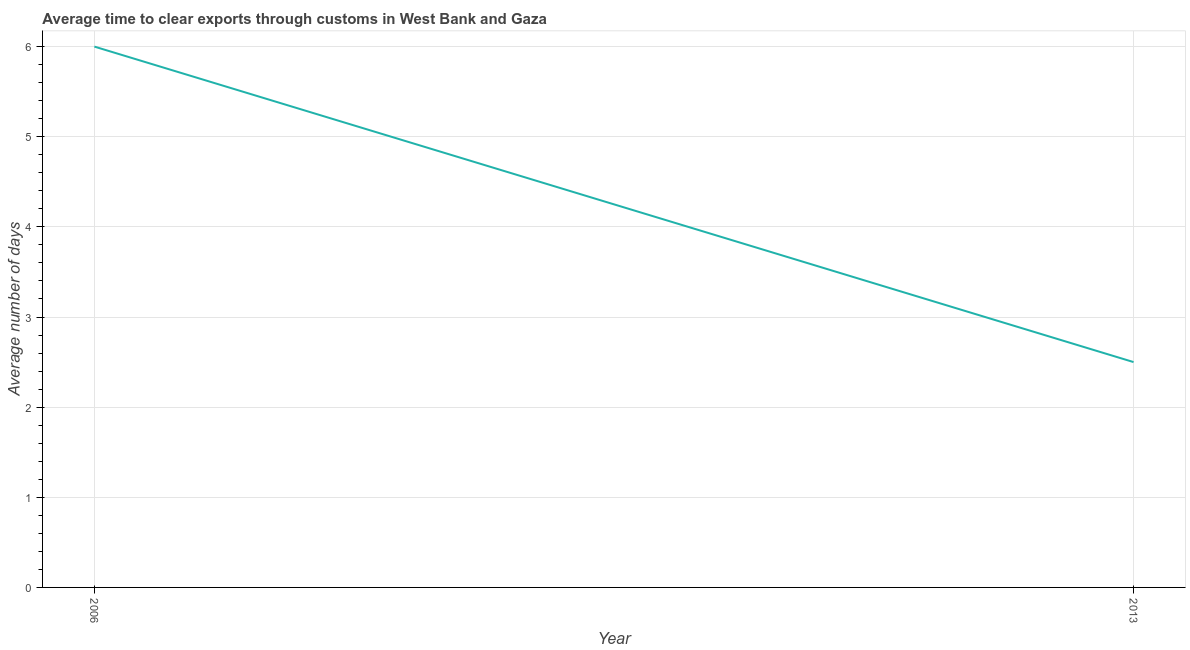Across all years, what is the minimum time to clear exports through customs?
Offer a very short reply. 2.5. What is the difference between the time to clear exports through customs in 2006 and 2013?
Keep it short and to the point. 3.5. What is the average time to clear exports through customs per year?
Provide a short and direct response. 4.25. What is the median time to clear exports through customs?
Offer a terse response. 4.25. In how many years, is the time to clear exports through customs greater than 1.4 days?
Offer a very short reply. 2. In how many years, is the time to clear exports through customs greater than the average time to clear exports through customs taken over all years?
Your answer should be very brief. 1. Does the time to clear exports through customs monotonically increase over the years?
Offer a terse response. No. How many lines are there?
Give a very brief answer. 1. How many years are there in the graph?
Offer a very short reply. 2. What is the difference between two consecutive major ticks on the Y-axis?
Your answer should be very brief. 1. Does the graph contain grids?
Make the answer very short. Yes. What is the title of the graph?
Offer a terse response. Average time to clear exports through customs in West Bank and Gaza. What is the label or title of the Y-axis?
Ensure brevity in your answer.  Average number of days. What is the Average number of days in 2006?
Provide a succinct answer. 6. 